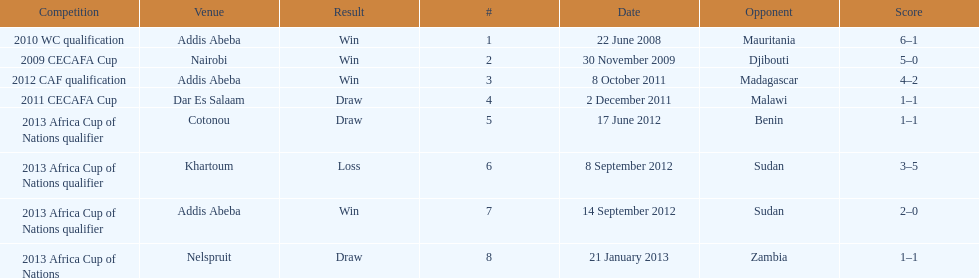Number of different teams listed on the chart 7. 